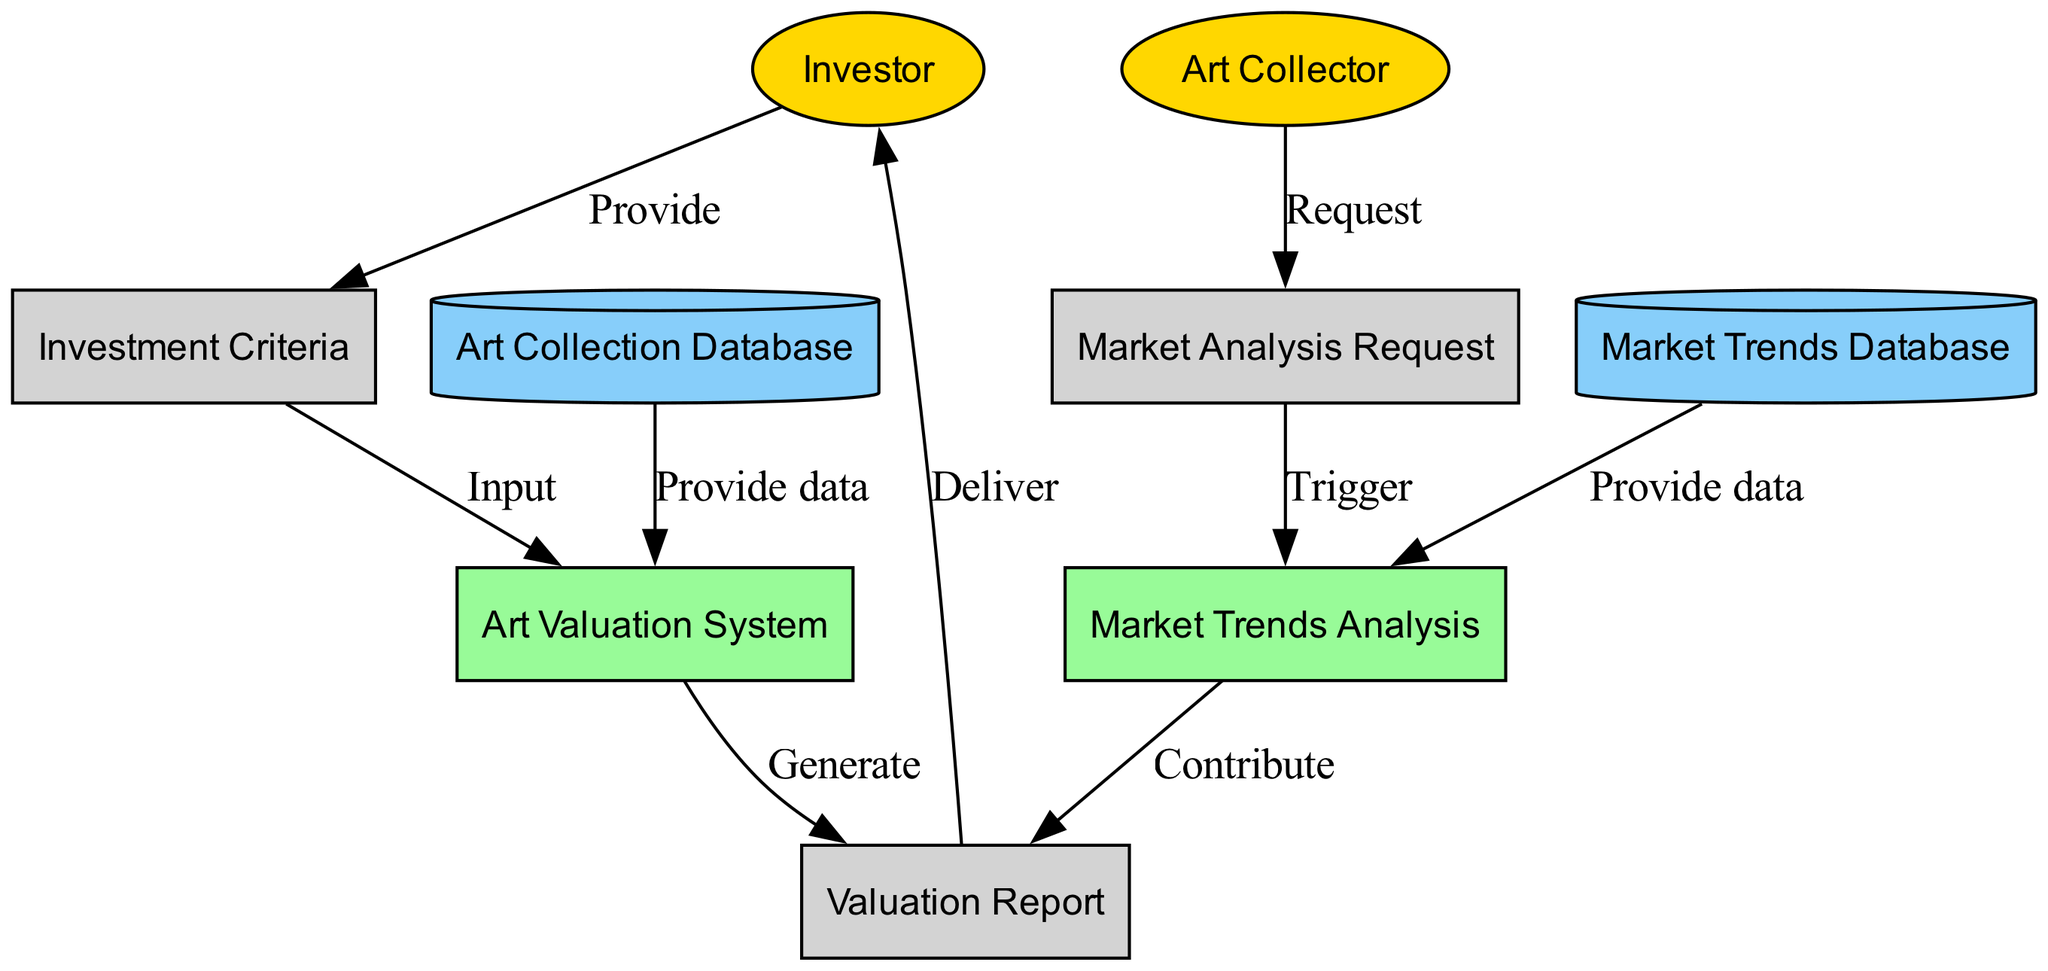What is the role of the Investor in the diagram? The Investor is an external entity seeking investment advice on art, which is indicated by the labeled node.
Answer: Investor How many data stores are present in the diagram? The diagram shows two data stores: the Art Collection Database and the Market Trends Database. Therefore, by counting these nodes, we can ascertain the total.
Answer: 2 What does the Art Valuation System generate? According to the diagram, the Art Valuation System generates a Valuation Report, which is specifically labeled as the output of this process.
Answer: Valuation Report What type of data flow does the Art Collector send? The Art Collector sends a Market Analysis Request to the Market Trends Analysis process, as outlined by the corresponding labeled arrow.
Answer: Market Analysis Request Which external entity provides criteria for art investment? The Investor is the external entity that provides Investment Criteria, shown by the connecting arrow in the diagram.
Answer: Investor How many processes are depicted in the diagram? By examining the diagram's components, we identify two processes: the Art Valuation System and the Market Trends Analysis, affirming their roles in the data flow.
Answer: 2 What triggers the Market Trends Analysis process? The trigger for the Market Trends Analysis process is the Market Analysis Request sent by the Art Collector, as depicted in the diagram.
Answer: Market Analysis Request What is the relationship between the Valuation Report and the Investor? The Valuation Report is delivered to the Investor, as indicated by the arrow connecting these two elements in the diagram.
Answer: Deliver Which data store provides data to the Art Valuation System? The Art Collection Database provides data to the Art Valuation System, as shown by the directed edge leading from the data store to the process.
Answer: Art Collection Database 